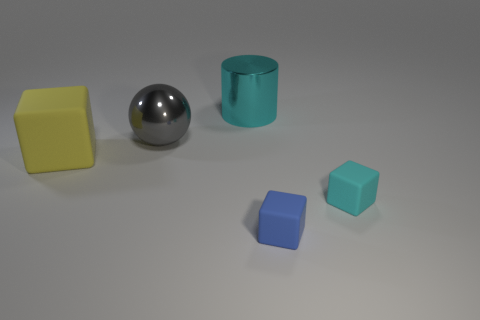There is a cyan thing in front of the ball; what is its size?
Your answer should be compact. Small. There is a cyan object that is the same size as the yellow rubber thing; what is its shape?
Keep it short and to the point. Cylinder. Are the block that is behind the small cyan matte thing and the small object behind the blue rubber cube made of the same material?
Provide a short and direct response. Yes. What is the material of the small cube to the right of the tiny object in front of the tiny cyan block?
Ensure brevity in your answer.  Rubber. What size is the cyan object on the right side of the cyan thing that is behind the large thing in front of the big gray metal sphere?
Make the answer very short. Small. Is the size of the cyan cube the same as the blue cube?
Your response must be concise. Yes. There is a blue matte thing that is in front of the gray shiny thing; does it have the same shape as the cyan thing behind the big yellow block?
Your response must be concise. No. Are there any metal things on the left side of the cyan thing that is behind the yellow rubber thing?
Provide a short and direct response. Yes. Are any red rubber balls visible?
Your answer should be compact. No. What number of red rubber cylinders are the same size as the shiny sphere?
Your answer should be very brief. 0. 